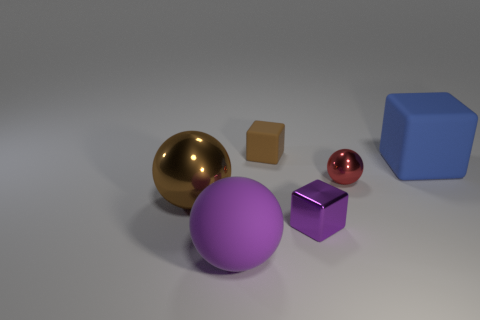There is a brown object behind the red object; does it have the same size as the metallic ball that is right of the big metallic thing?
Make the answer very short. Yes. There is a tiny thing that is both behind the large shiny ball and in front of the small brown rubber block; what shape is it?
Make the answer very short. Sphere. What color is the matte block that is to the right of the matte cube behind the big blue matte thing?
Give a very brief answer. Blue. There is a ball that is to the right of the big brown shiny thing and to the left of the small sphere; what material is it?
Your response must be concise. Rubber. There is a purple sphere; how many purple blocks are to the left of it?
Give a very brief answer. 0. Is the shape of the brown object on the right side of the large purple thing the same as  the small purple shiny object?
Give a very brief answer. Yes. Are there any other big things of the same shape as the large purple thing?
Provide a short and direct response. Yes. What material is the thing that is the same color as the rubber ball?
Your response must be concise. Metal. What is the shape of the rubber object in front of the small thing to the right of the purple metallic object?
Ensure brevity in your answer.  Sphere. What number of small purple blocks are made of the same material as the small ball?
Make the answer very short. 1. 